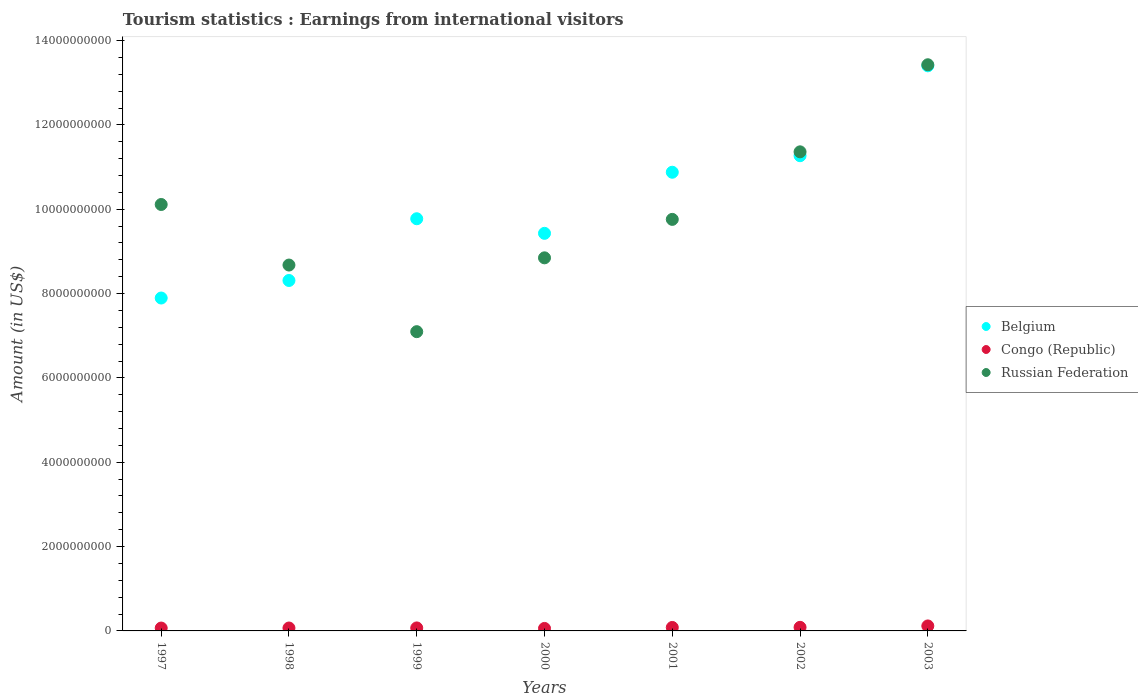How many different coloured dotlines are there?
Your answer should be compact. 3. Is the number of dotlines equal to the number of legend labels?
Keep it short and to the point. Yes. What is the earnings from international visitors in Congo (Republic) in 2003?
Give a very brief answer. 1.18e+08. Across all years, what is the maximum earnings from international visitors in Russian Federation?
Your answer should be compact. 1.34e+1. Across all years, what is the minimum earnings from international visitors in Russian Federation?
Your answer should be very brief. 7.10e+09. In which year was the earnings from international visitors in Russian Federation minimum?
Your answer should be compact. 1999. What is the total earnings from international visitors in Russian Federation in the graph?
Ensure brevity in your answer.  6.93e+1. What is the difference between the earnings from international visitors in Belgium in 1999 and that in 2003?
Give a very brief answer. -3.63e+09. What is the difference between the earnings from international visitors in Belgium in 2003 and the earnings from international visitors in Congo (Republic) in 1997?
Make the answer very short. 1.33e+1. What is the average earnings from international visitors in Belgium per year?
Offer a terse response. 1.01e+1. In the year 2000, what is the difference between the earnings from international visitors in Russian Federation and earnings from international visitors in Congo (Republic)?
Provide a short and direct response. 8.79e+09. What is the ratio of the earnings from international visitors in Belgium in 1997 to that in 2000?
Your answer should be very brief. 0.84. Is the earnings from international visitors in Belgium in 1999 less than that in 2003?
Give a very brief answer. Yes. Is the difference between the earnings from international visitors in Russian Federation in 1997 and 2000 greater than the difference between the earnings from international visitors in Congo (Republic) in 1997 and 2000?
Your response must be concise. Yes. What is the difference between the highest and the second highest earnings from international visitors in Congo (Republic)?
Your answer should be compact. 3.30e+07. What is the difference between the highest and the lowest earnings from international visitors in Belgium?
Ensure brevity in your answer.  5.51e+09. Is the sum of the earnings from international visitors in Russian Federation in 1997 and 2000 greater than the maximum earnings from international visitors in Belgium across all years?
Make the answer very short. Yes. Is the earnings from international visitors in Russian Federation strictly greater than the earnings from international visitors in Congo (Republic) over the years?
Make the answer very short. Yes. Is the earnings from international visitors in Congo (Republic) strictly less than the earnings from international visitors in Russian Federation over the years?
Your response must be concise. Yes. How many dotlines are there?
Make the answer very short. 3. What is the difference between two consecutive major ticks on the Y-axis?
Offer a very short reply. 2.00e+09. Are the values on the major ticks of Y-axis written in scientific E-notation?
Provide a short and direct response. No. Does the graph contain any zero values?
Your answer should be very brief. No. Does the graph contain grids?
Your answer should be compact. No. How many legend labels are there?
Make the answer very short. 3. How are the legend labels stacked?
Ensure brevity in your answer.  Vertical. What is the title of the graph?
Give a very brief answer. Tourism statistics : Earnings from international visitors. What is the label or title of the X-axis?
Offer a terse response. Years. What is the label or title of the Y-axis?
Provide a short and direct response. Amount (in US$). What is the Amount (in US$) in Belgium in 1997?
Provide a short and direct response. 7.90e+09. What is the Amount (in US$) in Congo (Republic) in 1997?
Offer a terse response. 6.80e+07. What is the Amount (in US$) of Russian Federation in 1997?
Your answer should be very brief. 1.01e+1. What is the Amount (in US$) of Belgium in 1998?
Your response must be concise. 8.31e+09. What is the Amount (in US$) in Congo (Republic) in 1998?
Keep it short and to the point. 6.90e+07. What is the Amount (in US$) in Russian Federation in 1998?
Keep it short and to the point. 8.68e+09. What is the Amount (in US$) of Belgium in 1999?
Provide a succinct answer. 9.78e+09. What is the Amount (in US$) of Congo (Republic) in 1999?
Your answer should be compact. 7.10e+07. What is the Amount (in US$) of Russian Federation in 1999?
Provide a short and direct response. 7.10e+09. What is the Amount (in US$) of Belgium in 2000?
Your response must be concise. 9.43e+09. What is the Amount (in US$) in Congo (Republic) in 2000?
Provide a short and direct response. 5.90e+07. What is the Amount (in US$) in Russian Federation in 2000?
Offer a terse response. 8.85e+09. What is the Amount (in US$) of Belgium in 2001?
Provide a short and direct response. 1.09e+1. What is the Amount (in US$) of Congo (Republic) in 2001?
Provide a succinct answer. 8.20e+07. What is the Amount (in US$) in Russian Federation in 2001?
Give a very brief answer. 9.76e+09. What is the Amount (in US$) of Belgium in 2002?
Offer a very short reply. 1.13e+1. What is the Amount (in US$) in Congo (Republic) in 2002?
Your response must be concise. 8.50e+07. What is the Amount (in US$) in Russian Federation in 2002?
Make the answer very short. 1.14e+1. What is the Amount (in US$) of Belgium in 2003?
Make the answer very short. 1.34e+1. What is the Amount (in US$) of Congo (Republic) in 2003?
Keep it short and to the point. 1.18e+08. What is the Amount (in US$) in Russian Federation in 2003?
Ensure brevity in your answer.  1.34e+1. Across all years, what is the maximum Amount (in US$) in Belgium?
Make the answer very short. 1.34e+1. Across all years, what is the maximum Amount (in US$) in Congo (Republic)?
Your answer should be very brief. 1.18e+08. Across all years, what is the maximum Amount (in US$) in Russian Federation?
Your answer should be compact. 1.34e+1. Across all years, what is the minimum Amount (in US$) of Belgium?
Your response must be concise. 7.90e+09. Across all years, what is the minimum Amount (in US$) of Congo (Republic)?
Keep it short and to the point. 5.90e+07. Across all years, what is the minimum Amount (in US$) of Russian Federation?
Ensure brevity in your answer.  7.10e+09. What is the total Amount (in US$) in Belgium in the graph?
Your answer should be compact. 7.10e+1. What is the total Amount (in US$) of Congo (Republic) in the graph?
Your response must be concise. 5.52e+08. What is the total Amount (in US$) in Russian Federation in the graph?
Your response must be concise. 6.93e+1. What is the difference between the Amount (in US$) of Belgium in 1997 and that in 1998?
Provide a succinct answer. -4.16e+08. What is the difference between the Amount (in US$) of Russian Federation in 1997 and that in 1998?
Provide a succinct answer. 1.44e+09. What is the difference between the Amount (in US$) of Belgium in 1997 and that in 1999?
Your response must be concise. -1.88e+09. What is the difference between the Amount (in US$) of Congo (Republic) in 1997 and that in 1999?
Offer a terse response. -3.00e+06. What is the difference between the Amount (in US$) of Russian Federation in 1997 and that in 1999?
Your answer should be compact. 3.02e+09. What is the difference between the Amount (in US$) in Belgium in 1997 and that in 2000?
Keep it short and to the point. -1.53e+09. What is the difference between the Amount (in US$) in Congo (Republic) in 1997 and that in 2000?
Your answer should be very brief. 9.00e+06. What is the difference between the Amount (in US$) in Russian Federation in 1997 and that in 2000?
Your answer should be very brief. 1.26e+09. What is the difference between the Amount (in US$) of Belgium in 1997 and that in 2001?
Ensure brevity in your answer.  -2.98e+09. What is the difference between the Amount (in US$) in Congo (Republic) in 1997 and that in 2001?
Make the answer very short. -1.40e+07. What is the difference between the Amount (in US$) of Russian Federation in 1997 and that in 2001?
Keep it short and to the point. 3.53e+08. What is the difference between the Amount (in US$) in Belgium in 1997 and that in 2002?
Make the answer very short. -3.38e+09. What is the difference between the Amount (in US$) of Congo (Republic) in 1997 and that in 2002?
Give a very brief answer. -1.70e+07. What is the difference between the Amount (in US$) in Russian Federation in 1997 and that in 2002?
Your answer should be compact. -1.25e+09. What is the difference between the Amount (in US$) in Belgium in 1997 and that in 2003?
Provide a succinct answer. -5.51e+09. What is the difference between the Amount (in US$) of Congo (Republic) in 1997 and that in 2003?
Give a very brief answer. -5.00e+07. What is the difference between the Amount (in US$) in Russian Federation in 1997 and that in 2003?
Give a very brief answer. -3.31e+09. What is the difference between the Amount (in US$) of Belgium in 1998 and that in 1999?
Offer a terse response. -1.46e+09. What is the difference between the Amount (in US$) in Congo (Republic) in 1998 and that in 1999?
Make the answer very short. -2.00e+06. What is the difference between the Amount (in US$) of Russian Federation in 1998 and that in 1999?
Ensure brevity in your answer.  1.58e+09. What is the difference between the Amount (in US$) of Belgium in 1998 and that in 2000?
Provide a short and direct response. -1.12e+09. What is the difference between the Amount (in US$) in Congo (Republic) in 1998 and that in 2000?
Offer a terse response. 1.00e+07. What is the difference between the Amount (in US$) of Russian Federation in 1998 and that in 2000?
Your response must be concise. -1.71e+08. What is the difference between the Amount (in US$) of Belgium in 1998 and that in 2001?
Provide a succinct answer. -2.57e+09. What is the difference between the Amount (in US$) in Congo (Republic) in 1998 and that in 2001?
Your answer should be very brief. -1.30e+07. What is the difference between the Amount (in US$) of Russian Federation in 1998 and that in 2001?
Give a very brief answer. -1.08e+09. What is the difference between the Amount (in US$) in Belgium in 1998 and that in 2002?
Offer a very short reply. -2.96e+09. What is the difference between the Amount (in US$) in Congo (Republic) in 1998 and that in 2002?
Offer a terse response. -1.60e+07. What is the difference between the Amount (in US$) in Russian Federation in 1998 and that in 2002?
Your answer should be very brief. -2.68e+09. What is the difference between the Amount (in US$) in Belgium in 1998 and that in 2003?
Ensure brevity in your answer.  -5.09e+09. What is the difference between the Amount (in US$) of Congo (Republic) in 1998 and that in 2003?
Keep it short and to the point. -4.90e+07. What is the difference between the Amount (in US$) in Russian Federation in 1998 and that in 2003?
Your answer should be compact. -4.75e+09. What is the difference between the Amount (in US$) of Belgium in 1999 and that in 2000?
Your answer should be compact. 3.46e+08. What is the difference between the Amount (in US$) of Congo (Republic) in 1999 and that in 2000?
Ensure brevity in your answer.  1.20e+07. What is the difference between the Amount (in US$) in Russian Federation in 1999 and that in 2000?
Your answer should be very brief. -1.75e+09. What is the difference between the Amount (in US$) in Belgium in 1999 and that in 2001?
Offer a terse response. -1.10e+09. What is the difference between the Amount (in US$) of Congo (Republic) in 1999 and that in 2001?
Keep it short and to the point. -1.10e+07. What is the difference between the Amount (in US$) in Russian Federation in 1999 and that in 2001?
Your answer should be compact. -2.66e+09. What is the difference between the Amount (in US$) in Belgium in 1999 and that in 2002?
Make the answer very short. -1.50e+09. What is the difference between the Amount (in US$) of Congo (Republic) in 1999 and that in 2002?
Keep it short and to the point. -1.40e+07. What is the difference between the Amount (in US$) of Russian Federation in 1999 and that in 2002?
Make the answer very short. -4.26e+09. What is the difference between the Amount (in US$) in Belgium in 1999 and that in 2003?
Provide a short and direct response. -3.63e+09. What is the difference between the Amount (in US$) of Congo (Republic) in 1999 and that in 2003?
Keep it short and to the point. -4.70e+07. What is the difference between the Amount (in US$) of Russian Federation in 1999 and that in 2003?
Offer a very short reply. -6.33e+09. What is the difference between the Amount (in US$) in Belgium in 2000 and that in 2001?
Give a very brief answer. -1.45e+09. What is the difference between the Amount (in US$) of Congo (Republic) in 2000 and that in 2001?
Your response must be concise. -2.30e+07. What is the difference between the Amount (in US$) of Russian Federation in 2000 and that in 2001?
Your answer should be compact. -9.12e+08. What is the difference between the Amount (in US$) of Belgium in 2000 and that in 2002?
Give a very brief answer. -1.84e+09. What is the difference between the Amount (in US$) in Congo (Republic) in 2000 and that in 2002?
Offer a very short reply. -2.60e+07. What is the difference between the Amount (in US$) of Russian Federation in 2000 and that in 2002?
Provide a short and direct response. -2.51e+09. What is the difference between the Amount (in US$) of Belgium in 2000 and that in 2003?
Keep it short and to the point. -3.97e+09. What is the difference between the Amount (in US$) of Congo (Republic) in 2000 and that in 2003?
Ensure brevity in your answer.  -5.90e+07. What is the difference between the Amount (in US$) of Russian Federation in 2000 and that in 2003?
Provide a short and direct response. -4.58e+09. What is the difference between the Amount (in US$) of Belgium in 2001 and that in 2002?
Your answer should be very brief. -3.92e+08. What is the difference between the Amount (in US$) of Russian Federation in 2001 and that in 2002?
Make the answer very short. -1.60e+09. What is the difference between the Amount (in US$) in Belgium in 2001 and that in 2003?
Provide a succinct answer. -2.52e+09. What is the difference between the Amount (in US$) in Congo (Republic) in 2001 and that in 2003?
Make the answer very short. -3.60e+07. What is the difference between the Amount (in US$) in Russian Federation in 2001 and that in 2003?
Offer a terse response. -3.67e+09. What is the difference between the Amount (in US$) of Belgium in 2002 and that in 2003?
Your response must be concise. -2.13e+09. What is the difference between the Amount (in US$) in Congo (Republic) in 2002 and that in 2003?
Ensure brevity in your answer.  -3.30e+07. What is the difference between the Amount (in US$) of Russian Federation in 2002 and that in 2003?
Offer a terse response. -2.06e+09. What is the difference between the Amount (in US$) in Belgium in 1997 and the Amount (in US$) in Congo (Republic) in 1998?
Ensure brevity in your answer.  7.83e+09. What is the difference between the Amount (in US$) in Belgium in 1997 and the Amount (in US$) in Russian Federation in 1998?
Your response must be concise. -7.82e+08. What is the difference between the Amount (in US$) of Congo (Republic) in 1997 and the Amount (in US$) of Russian Federation in 1998?
Your answer should be very brief. -8.61e+09. What is the difference between the Amount (in US$) of Belgium in 1997 and the Amount (in US$) of Congo (Republic) in 1999?
Provide a short and direct response. 7.82e+09. What is the difference between the Amount (in US$) of Belgium in 1997 and the Amount (in US$) of Russian Federation in 1999?
Provide a short and direct response. 7.98e+08. What is the difference between the Amount (in US$) in Congo (Republic) in 1997 and the Amount (in US$) in Russian Federation in 1999?
Keep it short and to the point. -7.03e+09. What is the difference between the Amount (in US$) of Belgium in 1997 and the Amount (in US$) of Congo (Republic) in 2000?
Your response must be concise. 7.84e+09. What is the difference between the Amount (in US$) in Belgium in 1997 and the Amount (in US$) in Russian Federation in 2000?
Offer a very short reply. -9.53e+08. What is the difference between the Amount (in US$) in Congo (Republic) in 1997 and the Amount (in US$) in Russian Federation in 2000?
Your answer should be compact. -8.78e+09. What is the difference between the Amount (in US$) in Belgium in 1997 and the Amount (in US$) in Congo (Republic) in 2001?
Provide a short and direct response. 7.81e+09. What is the difference between the Amount (in US$) in Belgium in 1997 and the Amount (in US$) in Russian Federation in 2001?
Keep it short and to the point. -1.86e+09. What is the difference between the Amount (in US$) in Congo (Republic) in 1997 and the Amount (in US$) in Russian Federation in 2001?
Offer a terse response. -9.69e+09. What is the difference between the Amount (in US$) in Belgium in 1997 and the Amount (in US$) in Congo (Republic) in 2002?
Ensure brevity in your answer.  7.81e+09. What is the difference between the Amount (in US$) in Belgium in 1997 and the Amount (in US$) in Russian Federation in 2002?
Ensure brevity in your answer.  -3.47e+09. What is the difference between the Amount (in US$) in Congo (Republic) in 1997 and the Amount (in US$) in Russian Federation in 2002?
Make the answer very short. -1.13e+1. What is the difference between the Amount (in US$) of Belgium in 1997 and the Amount (in US$) of Congo (Republic) in 2003?
Your answer should be very brief. 7.78e+09. What is the difference between the Amount (in US$) in Belgium in 1997 and the Amount (in US$) in Russian Federation in 2003?
Your response must be concise. -5.53e+09. What is the difference between the Amount (in US$) of Congo (Republic) in 1997 and the Amount (in US$) of Russian Federation in 2003?
Your answer should be compact. -1.34e+1. What is the difference between the Amount (in US$) in Belgium in 1998 and the Amount (in US$) in Congo (Republic) in 1999?
Make the answer very short. 8.24e+09. What is the difference between the Amount (in US$) in Belgium in 1998 and the Amount (in US$) in Russian Federation in 1999?
Ensure brevity in your answer.  1.21e+09. What is the difference between the Amount (in US$) of Congo (Republic) in 1998 and the Amount (in US$) of Russian Federation in 1999?
Make the answer very short. -7.03e+09. What is the difference between the Amount (in US$) of Belgium in 1998 and the Amount (in US$) of Congo (Republic) in 2000?
Provide a succinct answer. 8.25e+09. What is the difference between the Amount (in US$) in Belgium in 1998 and the Amount (in US$) in Russian Federation in 2000?
Your answer should be compact. -5.37e+08. What is the difference between the Amount (in US$) of Congo (Republic) in 1998 and the Amount (in US$) of Russian Federation in 2000?
Provide a succinct answer. -8.78e+09. What is the difference between the Amount (in US$) of Belgium in 1998 and the Amount (in US$) of Congo (Republic) in 2001?
Keep it short and to the point. 8.23e+09. What is the difference between the Amount (in US$) of Belgium in 1998 and the Amount (in US$) of Russian Federation in 2001?
Offer a very short reply. -1.45e+09. What is the difference between the Amount (in US$) in Congo (Republic) in 1998 and the Amount (in US$) in Russian Federation in 2001?
Your answer should be very brief. -9.69e+09. What is the difference between the Amount (in US$) in Belgium in 1998 and the Amount (in US$) in Congo (Republic) in 2002?
Your answer should be compact. 8.23e+09. What is the difference between the Amount (in US$) in Belgium in 1998 and the Amount (in US$) in Russian Federation in 2002?
Provide a short and direct response. -3.05e+09. What is the difference between the Amount (in US$) of Congo (Republic) in 1998 and the Amount (in US$) of Russian Federation in 2002?
Provide a short and direct response. -1.13e+1. What is the difference between the Amount (in US$) in Belgium in 1998 and the Amount (in US$) in Congo (Republic) in 2003?
Ensure brevity in your answer.  8.19e+09. What is the difference between the Amount (in US$) of Belgium in 1998 and the Amount (in US$) of Russian Federation in 2003?
Provide a succinct answer. -5.12e+09. What is the difference between the Amount (in US$) in Congo (Republic) in 1998 and the Amount (in US$) in Russian Federation in 2003?
Provide a succinct answer. -1.34e+1. What is the difference between the Amount (in US$) of Belgium in 1999 and the Amount (in US$) of Congo (Republic) in 2000?
Your response must be concise. 9.72e+09. What is the difference between the Amount (in US$) of Belgium in 1999 and the Amount (in US$) of Russian Federation in 2000?
Your answer should be very brief. 9.27e+08. What is the difference between the Amount (in US$) in Congo (Republic) in 1999 and the Amount (in US$) in Russian Federation in 2000?
Give a very brief answer. -8.78e+09. What is the difference between the Amount (in US$) in Belgium in 1999 and the Amount (in US$) in Congo (Republic) in 2001?
Make the answer very short. 9.69e+09. What is the difference between the Amount (in US$) in Belgium in 1999 and the Amount (in US$) in Russian Federation in 2001?
Give a very brief answer. 1.50e+07. What is the difference between the Amount (in US$) of Congo (Republic) in 1999 and the Amount (in US$) of Russian Federation in 2001?
Ensure brevity in your answer.  -9.69e+09. What is the difference between the Amount (in US$) of Belgium in 1999 and the Amount (in US$) of Congo (Republic) in 2002?
Offer a very short reply. 9.69e+09. What is the difference between the Amount (in US$) of Belgium in 1999 and the Amount (in US$) of Russian Federation in 2002?
Offer a terse response. -1.59e+09. What is the difference between the Amount (in US$) in Congo (Republic) in 1999 and the Amount (in US$) in Russian Federation in 2002?
Your response must be concise. -1.13e+1. What is the difference between the Amount (in US$) in Belgium in 1999 and the Amount (in US$) in Congo (Republic) in 2003?
Give a very brief answer. 9.66e+09. What is the difference between the Amount (in US$) in Belgium in 1999 and the Amount (in US$) in Russian Federation in 2003?
Offer a terse response. -3.65e+09. What is the difference between the Amount (in US$) of Congo (Republic) in 1999 and the Amount (in US$) of Russian Federation in 2003?
Provide a short and direct response. -1.34e+1. What is the difference between the Amount (in US$) of Belgium in 2000 and the Amount (in US$) of Congo (Republic) in 2001?
Your response must be concise. 9.35e+09. What is the difference between the Amount (in US$) in Belgium in 2000 and the Amount (in US$) in Russian Federation in 2001?
Your answer should be compact. -3.31e+08. What is the difference between the Amount (in US$) of Congo (Republic) in 2000 and the Amount (in US$) of Russian Federation in 2001?
Make the answer very short. -9.70e+09. What is the difference between the Amount (in US$) in Belgium in 2000 and the Amount (in US$) in Congo (Republic) in 2002?
Make the answer very short. 9.34e+09. What is the difference between the Amount (in US$) of Belgium in 2000 and the Amount (in US$) of Russian Federation in 2002?
Keep it short and to the point. -1.93e+09. What is the difference between the Amount (in US$) in Congo (Republic) in 2000 and the Amount (in US$) in Russian Federation in 2002?
Offer a very short reply. -1.13e+1. What is the difference between the Amount (in US$) in Belgium in 2000 and the Amount (in US$) in Congo (Republic) in 2003?
Ensure brevity in your answer.  9.31e+09. What is the difference between the Amount (in US$) in Belgium in 2000 and the Amount (in US$) in Russian Federation in 2003?
Provide a short and direct response. -4.00e+09. What is the difference between the Amount (in US$) of Congo (Republic) in 2000 and the Amount (in US$) of Russian Federation in 2003?
Give a very brief answer. -1.34e+1. What is the difference between the Amount (in US$) in Belgium in 2001 and the Amount (in US$) in Congo (Republic) in 2002?
Offer a terse response. 1.08e+1. What is the difference between the Amount (in US$) in Belgium in 2001 and the Amount (in US$) in Russian Federation in 2002?
Provide a succinct answer. -4.84e+08. What is the difference between the Amount (in US$) of Congo (Republic) in 2001 and the Amount (in US$) of Russian Federation in 2002?
Give a very brief answer. -1.13e+1. What is the difference between the Amount (in US$) of Belgium in 2001 and the Amount (in US$) of Congo (Republic) in 2003?
Your answer should be very brief. 1.08e+1. What is the difference between the Amount (in US$) in Belgium in 2001 and the Amount (in US$) in Russian Federation in 2003?
Your response must be concise. -2.55e+09. What is the difference between the Amount (in US$) of Congo (Republic) in 2001 and the Amount (in US$) of Russian Federation in 2003?
Provide a succinct answer. -1.33e+1. What is the difference between the Amount (in US$) in Belgium in 2002 and the Amount (in US$) in Congo (Republic) in 2003?
Keep it short and to the point. 1.12e+1. What is the difference between the Amount (in US$) of Belgium in 2002 and the Amount (in US$) of Russian Federation in 2003?
Your response must be concise. -2.16e+09. What is the difference between the Amount (in US$) in Congo (Republic) in 2002 and the Amount (in US$) in Russian Federation in 2003?
Keep it short and to the point. -1.33e+1. What is the average Amount (in US$) in Belgium per year?
Offer a terse response. 1.01e+1. What is the average Amount (in US$) in Congo (Republic) per year?
Your answer should be very brief. 7.89e+07. What is the average Amount (in US$) of Russian Federation per year?
Provide a succinct answer. 9.90e+09. In the year 1997, what is the difference between the Amount (in US$) in Belgium and Amount (in US$) in Congo (Republic)?
Your response must be concise. 7.83e+09. In the year 1997, what is the difference between the Amount (in US$) in Belgium and Amount (in US$) in Russian Federation?
Provide a short and direct response. -2.22e+09. In the year 1997, what is the difference between the Amount (in US$) of Congo (Republic) and Amount (in US$) of Russian Federation?
Give a very brief answer. -1.00e+1. In the year 1998, what is the difference between the Amount (in US$) in Belgium and Amount (in US$) in Congo (Republic)?
Offer a very short reply. 8.24e+09. In the year 1998, what is the difference between the Amount (in US$) of Belgium and Amount (in US$) of Russian Federation?
Your response must be concise. -3.66e+08. In the year 1998, what is the difference between the Amount (in US$) of Congo (Republic) and Amount (in US$) of Russian Federation?
Ensure brevity in your answer.  -8.61e+09. In the year 1999, what is the difference between the Amount (in US$) in Belgium and Amount (in US$) in Congo (Republic)?
Your response must be concise. 9.70e+09. In the year 1999, what is the difference between the Amount (in US$) in Belgium and Amount (in US$) in Russian Federation?
Provide a succinct answer. 2.68e+09. In the year 1999, what is the difference between the Amount (in US$) of Congo (Republic) and Amount (in US$) of Russian Federation?
Give a very brief answer. -7.03e+09. In the year 2000, what is the difference between the Amount (in US$) of Belgium and Amount (in US$) of Congo (Republic)?
Keep it short and to the point. 9.37e+09. In the year 2000, what is the difference between the Amount (in US$) of Belgium and Amount (in US$) of Russian Federation?
Ensure brevity in your answer.  5.81e+08. In the year 2000, what is the difference between the Amount (in US$) of Congo (Republic) and Amount (in US$) of Russian Federation?
Your answer should be compact. -8.79e+09. In the year 2001, what is the difference between the Amount (in US$) of Belgium and Amount (in US$) of Congo (Republic)?
Keep it short and to the point. 1.08e+1. In the year 2001, what is the difference between the Amount (in US$) in Belgium and Amount (in US$) in Russian Federation?
Offer a terse response. 1.12e+09. In the year 2001, what is the difference between the Amount (in US$) in Congo (Republic) and Amount (in US$) in Russian Federation?
Provide a short and direct response. -9.68e+09. In the year 2002, what is the difference between the Amount (in US$) in Belgium and Amount (in US$) in Congo (Republic)?
Make the answer very short. 1.12e+1. In the year 2002, what is the difference between the Amount (in US$) of Belgium and Amount (in US$) of Russian Federation?
Make the answer very short. -9.20e+07. In the year 2002, what is the difference between the Amount (in US$) of Congo (Republic) and Amount (in US$) of Russian Federation?
Your answer should be compact. -1.13e+1. In the year 2003, what is the difference between the Amount (in US$) of Belgium and Amount (in US$) of Congo (Republic)?
Make the answer very short. 1.33e+1. In the year 2003, what is the difference between the Amount (in US$) of Belgium and Amount (in US$) of Russian Federation?
Your answer should be very brief. -2.50e+07. In the year 2003, what is the difference between the Amount (in US$) in Congo (Republic) and Amount (in US$) in Russian Federation?
Give a very brief answer. -1.33e+1. What is the ratio of the Amount (in US$) in Belgium in 1997 to that in 1998?
Your answer should be very brief. 0.95. What is the ratio of the Amount (in US$) of Congo (Republic) in 1997 to that in 1998?
Provide a short and direct response. 0.99. What is the ratio of the Amount (in US$) of Russian Federation in 1997 to that in 1998?
Give a very brief answer. 1.17. What is the ratio of the Amount (in US$) of Belgium in 1997 to that in 1999?
Offer a terse response. 0.81. What is the ratio of the Amount (in US$) in Congo (Republic) in 1997 to that in 1999?
Offer a very short reply. 0.96. What is the ratio of the Amount (in US$) in Russian Federation in 1997 to that in 1999?
Your response must be concise. 1.43. What is the ratio of the Amount (in US$) of Belgium in 1997 to that in 2000?
Your response must be concise. 0.84. What is the ratio of the Amount (in US$) of Congo (Republic) in 1997 to that in 2000?
Make the answer very short. 1.15. What is the ratio of the Amount (in US$) of Russian Federation in 1997 to that in 2000?
Provide a short and direct response. 1.14. What is the ratio of the Amount (in US$) in Belgium in 1997 to that in 2001?
Your answer should be very brief. 0.73. What is the ratio of the Amount (in US$) in Congo (Republic) in 1997 to that in 2001?
Keep it short and to the point. 0.83. What is the ratio of the Amount (in US$) in Russian Federation in 1997 to that in 2001?
Keep it short and to the point. 1.04. What is the ratio of the Amount (in US$) in Belgium in 1997 to that in 2002?
Your answer should be very brief. 0.7. What is the ratio of the Amount (in US$) in Russian Federation in 1997 to that in 2002?
Your response must be concise. 0.89. What is the ratio of the Amount (in US$) in Belgium in 1997 to that in 2003?
Provide a succinct answer. 0.59. What is the ratio of the Amount (in US$) in Congo (Republic) in 1997 to that in 2003?
Offer a very short reply. 0.58. What is the ratio of the Amount (in US$) of Russian Federation in 1997 to that in 2003?
Keep it short and to the point. 0.75. What is the ratio of the Amount (in US$) of Belgium in 1998 to that in 1999?
Give a very brief answer. 0.85. What is the ratio of the Amount (in US$) in Congo (Republic) in 1998 to that in 1999?
Your answer should be very brief. 0.97. What is the ratio of the Amount (in US$) in Russian Federation in 1998 to that in 1999?
Make the answer very short. 1.22. What is the ratio of the Amount (in US$) in Belgium in 1998 to that in 2000?
Give a very brief answer. 0.88. What is the ratio of the Amount (in US$) in Congo (Republic) in 1998 to that in 2000?
Provide a succinct answer. 1.17. What is the ratio of the Amount (in US$) of Russian Federation in 1998 to that in 2000?
Provide a succinct answer. 0.98. What is the ratio of the Amount (in US$) in Belgium in 1998 to that in 2001?
Give a very brief answer. 0.76. What is the ratio of the Amount (in US$) in Congo (Republic) in 1998 to that in 2001?
Ensure brevity in your answer.  0.84. What is the ratio of the Amount (in US$) in Russian Federation in 1998 to that in 2001?
Your answer should be very brief. 0.89. What is the ratio of the Amount (in US$) of Belgium in 1998 to that in 2002?
Your answer should be compact. 0.74. What is the ratio of the Amount (in US$) in Congo (Republic) in 1998 to that in 2002?
Your answer should be very brief. 0.81. What is the ratio of the Amount (in US$) in Russian Federation in 1998 to that in 2002?
Keep it short and to the point. 0.76. What is the ratio of the Amount (in US$) of Belgium in 1998 to that in 2003?
Offer a terse response. 0.62. What is the ratio of the Amount (in US$) in Congo (Republic) in 1998 to that in 2003?
Your response must be concise. 0.58. What is the ratio of the Amount (in US$) of Russian Federation in 1998 to that in 2003?
Keep it short and to the point. 0.65. What is the ratio of the Amount (in US$) of Belgium in 1999 to that in 2000?
Make the answer very short. 1.04. What is the ratio of the Amount (in US$) in Congo (Republic) in 1999 to that in 2000?
Offer a terse response. 1.2. What is the ratio of the Amount (in US$) in Russian Federation in 1999 to that in 2000?
Make the answer very short. 0.8. What is the ratio of the Amount (in US$) in Belgium in 1999 to that in 2001?
Ensure brevity in your answer.  0.9. What is the ratio of the Amount (in US$) in Congo (Republic) in 1999 to that in 2001?
Keep it short and to the point. 0.87. What is the ratio of the Amount (in US$) in Russian Federation in 1999 to that in 2001?
Give a very brief answer. 0.73. What is the ratio of the Amount (in US$) in Belgium in 1999 to that in 2002?
Keep it short and to the point. 0.87. What is the ratio of the Amount (in US$) in Congo (Republic) in 1999 to that in 2002?
Offer a very short reply. 0.84. What is the ratio of the Amount (in US$) in Russian Federation in 1999 to that in 2002?
Your answer should be compact. 0.62. What is the ratio of the Amount (in US$) in Belgium in 1999 to that in 2003?
Your answer should be compact. 0.73. What is the ratio of the Amount (in US$) in Congo (Republic) in 1999 to that in 2003?
Ensure brevity in your answer.  0.6. What is the ratio of the Amount (in US$) of Russian Federation in 1999 to that in 2003?
Your response must be concise. 0.53. What is the ratio of the Amount (in US$) of Belgium in 2000 to that in 2001?
Your answer should be very brief. 0.87. What is the ratio of the Amount (in US$) of Congo (Republic) in 2000 to that in 2001?
Your answer should be very brief. 0.72. What is the ratio of the Amount (in US$) in Russian Federation in 2000 to that in 2001?
Provide a short and direct response. 0.91. What is the ratio of the Amount (in US$) in Belgium in 2000 to that in 2002?
Keep it short and to the point. 0.84. What is the ratio of the Amount (in US$) in Congo (Republic) in 2000 to that in 2002?
Provide a succinct answer. 0.69. What is the ratio of the Amount (in US$) of Russian Federation in 2000 to that in 2002?
Make the answer very short. 0.78. What is the ratio of the Amount (in US$) of Belgium in 2000 to that in 2003?
Provide a short and direct response. 0.7. What is the ratio of the Amount (in US$) in Russian Federation in 2000 to that in 2003?
Provide a succinct answer. 0.66. What is the ratio of the Amount (in US$) in Belgium in 2001 to that in 2002?
Provide a succinct answer. 0.97. What is the ratio of the Amount (in US$) of Congo (Republic) in 2001 to that in 2002?
Your answer should be compact. 0.96. What is the ratio of the Amount (in US$) in Russian Federation in 2001 to that in 2002?
Make the answer very short. 0.86. What is the ratio of the Amount (in US$) of Belgium in 2001 to that in 2003?
Provide a succinct answer. 0.81. What is the ratio of the Amount (in US$) in Congo (Republic) in 2001 to that in 2003?
Ensure brevity in your answer.  0.69. What is the ratio of the Amount (in US$) in Russian Federation in 2001 to that in 2003?
Provide a short and direct response. 0.73. What is the ratio of the Amount (in US$) in Belgium in 2002 to that in 2003?
Make the answer very short. 0.84. What is the ratio of the Amount (in US$) of Congo (Republic) in 2002 to that in 2003?
Ensure brevity in your answer.  0.72. What is the ratio of the Amount (in US$) of Russian Federation in 2002 to that in 2003?
Your response must be concise. 0.85. What is the difference between the highest and the second highest Amount (in US$) of Belgium?
Offer a very short reply. 2.13e+09. What is the difference between the highest and the second highest Amount (in US$) of Congo (Republic)?
Your answer should be compact. 3.30e+07. What is the difference between the highest and the second highest Amount (in US$) of Russian Federation?
Ensure brevity in your answer.  2.06e+09. What is the difference between the highest and the lowest Amount (in US$) of Belgium?
Offer a very short reply. 5.51e+09. What is the difference between the highest and the lowest Amount (in US$) of Congo (Republic)?
Your response must be concise. 5.90e+07. What is the difference between the highest and the lowest Amount (in US$) of Russian Federation?
Provide a short and direct response. 6.33e+09. 